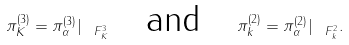Convert formula to latex. <formula><loc_0><loc_0><loc_500><loc_500>\pi ^ { ( 3 ) } _ { K } = \pi ^ { ( 3 ) } _ { \alpha } | _ { \ F _ { K } ^ { 3 } } \quad \text {and} \quad \pi ^ { ( 2 ) } _ { k } = \pi ^ { ( 2 ) } _ { \alpha } | _ { \ F _ { k } ^ { 2 } } .</formula> 